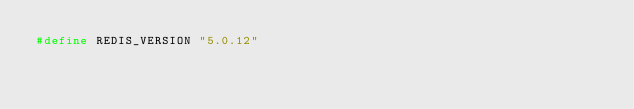<code> <loc_0><loc_0><loc_500><loc_500><_C_>#define REDIS_VERSION "5.0.12"
</code> 